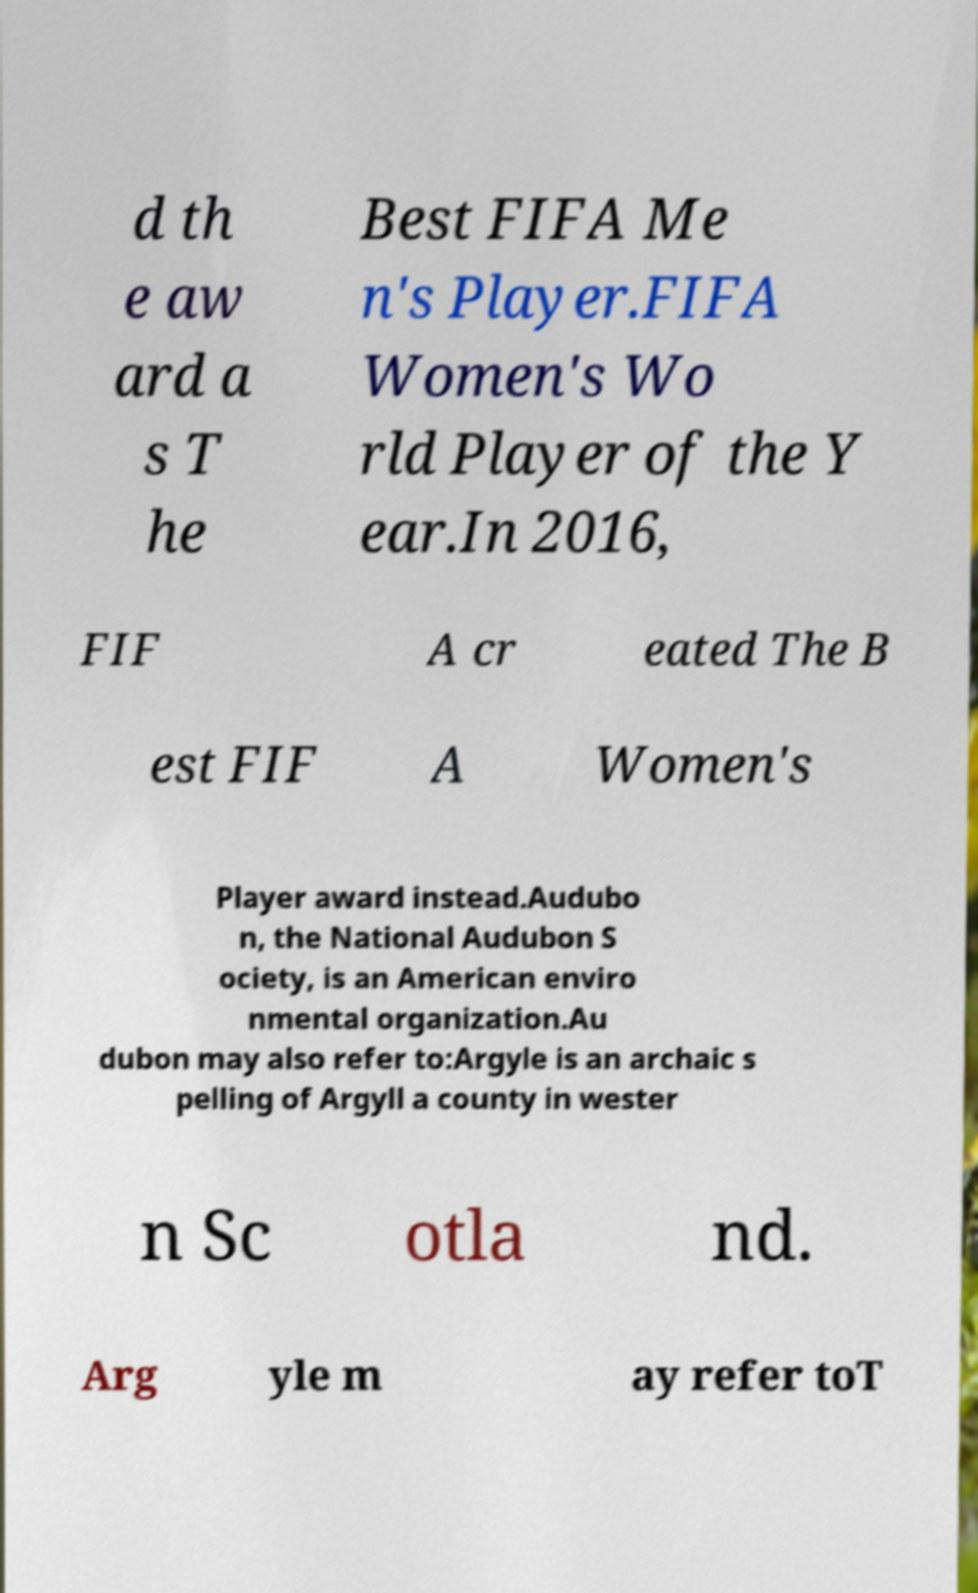What messages or text are displayed in this image? I need them in a readable, typed format. d th e aw ard a s T he Best FIFA Me n's Player.FIFA Women's Wo rld Player of the Y ear.In 2016, FIF A cr eated The B est FIF A Women's Player award instead.Audubo n, the National Audubon S ociety, is an American enviro nmental organization.Au dubon may also refer to:Argyle is an archaic s pelling of Argyll a county in wester n Sc otla nd. Arg yle m ay refer toT 